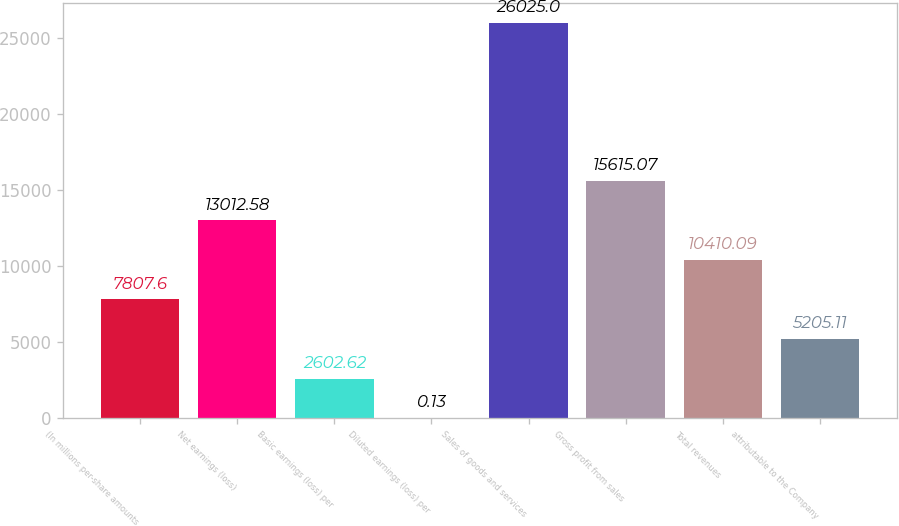<chart> <loc_0><loc_0><loc_500><loc_500><bar_chart><fcel>(In millions per-share amounts<fcel>Net earnings (loss)<fcel>Basic earnings (loss) per<fcel>Diluted earnings (loss) per<fcel>Sales of goods and services<fcel>Gross profit from sales<fcel>Total revenues<fcel>attributable to the Company<nl><fcel>7807.6<fcel>13012.6<fcel>2602.62<fcel>0.13<fcel>26025<fcel>15615.1<fcel>10410.1<fcel>5205.11<nl></chart> 